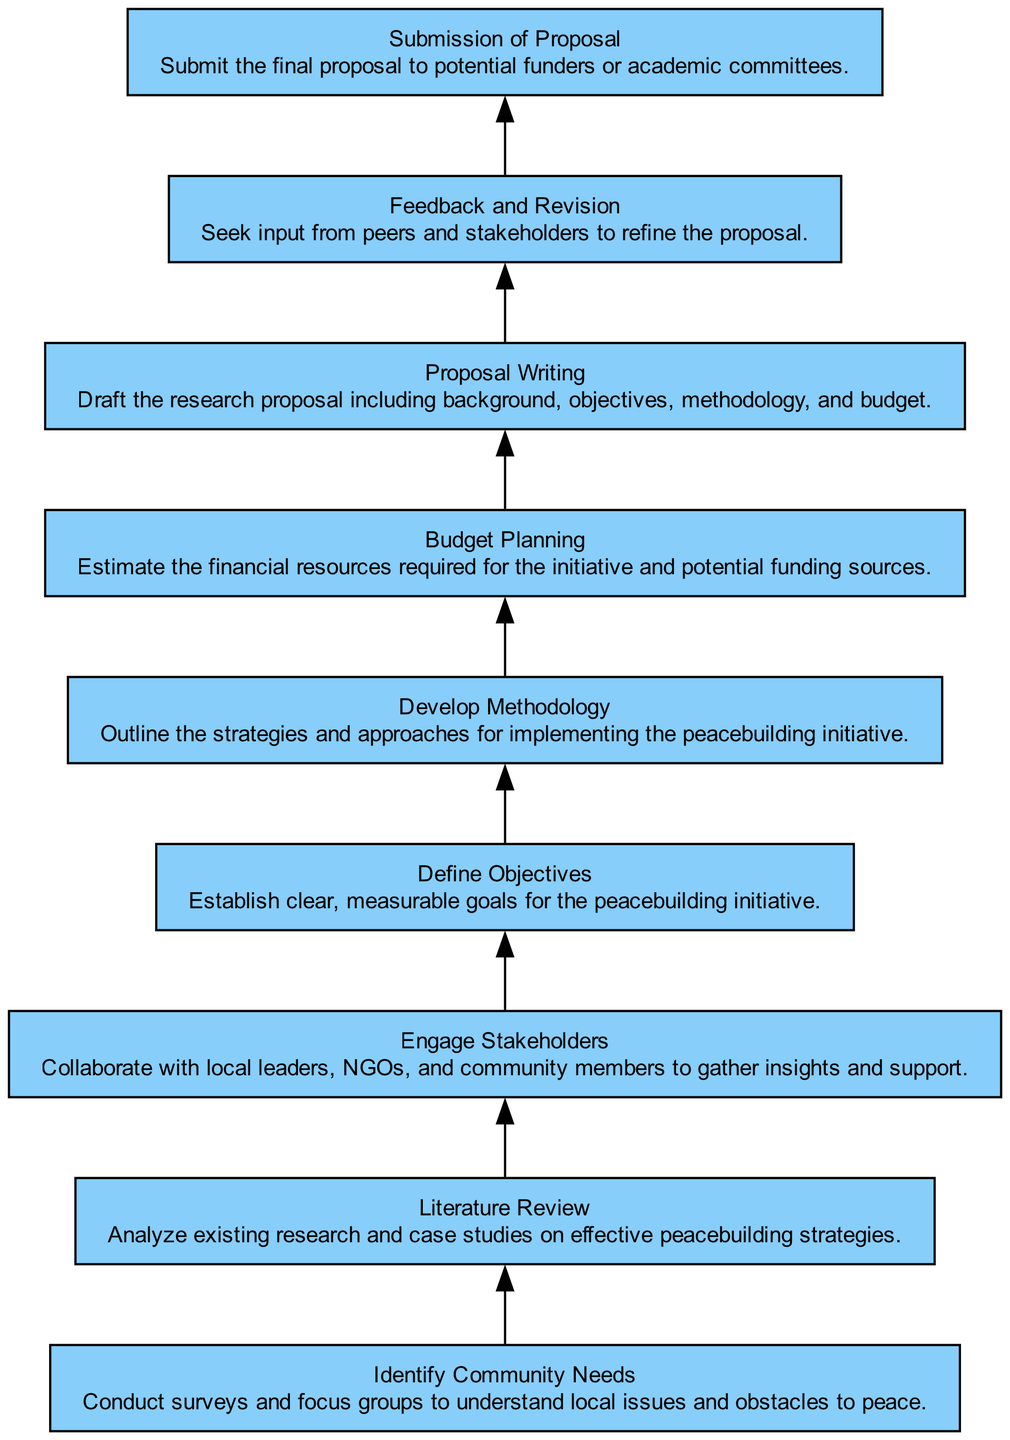What is the first step in the process? The diagram indicates that the first step is "Identify Community Needs," which is the first node in the flow.
Answer: Identify Community Needs How many nodes are present in the diagram? By counting each distinct element in the diagram, there are a total of nine nodes.
Answer: nine What is written in the node following "Literature Review"? The node that follows "Literature Review" is "Engage Stakeholders," as each node flows to the next in the order listed.
Answer: Engage Stakeholders Which node precedes "Budget Planning"? The node that immediately comes before "Budget Planning" is "Define Objectives." I can identify this by tracing the arrows from the nodes upward toward "Budget Planning."
Answer: Define Objectives What does the "Proposal Writing" node describe? The node "Proposal Writing" describes drafting the research proposal including background, objectives, methodology, and budget, as given in the diagram's description for this step.
Answer: Draft the research proposal including background, objectives, methodology, and budget Why is "Feedback and Revision" crucial in the development process? "Feedback and Revision" is crucial because it involves seeking input from peers and stakeholders to refine the proposal. This ensures the proposal is well-rounded and considers multiple viewpoints. This step is essential for improving the quality of the proposal based on collaborative insights.
Answer: To refine the proposal What type of relationships are represented in the chart? The relationships in the chart are sequential, as each node directly leads to the next, indicating a flow of processes that build on one another in the research proposal development.
Answer: Sequential What is the last step in the flow chart? The final step indicated in the diagram is "Submission of Proposal," which is the last node in the flow of the process.
Answer: Submission of Proposal How does "Engage Stakeholders" contribute to the "Define Objectives" step? "Engage Stakeholders" contributes to "Define Objectives" by providing insights and support from local leaders, NGOs, and community members, which helps in establishing clear, measurable goals that are informed by the community's needs and perspectives.
Answer: It enhances goal-setting 